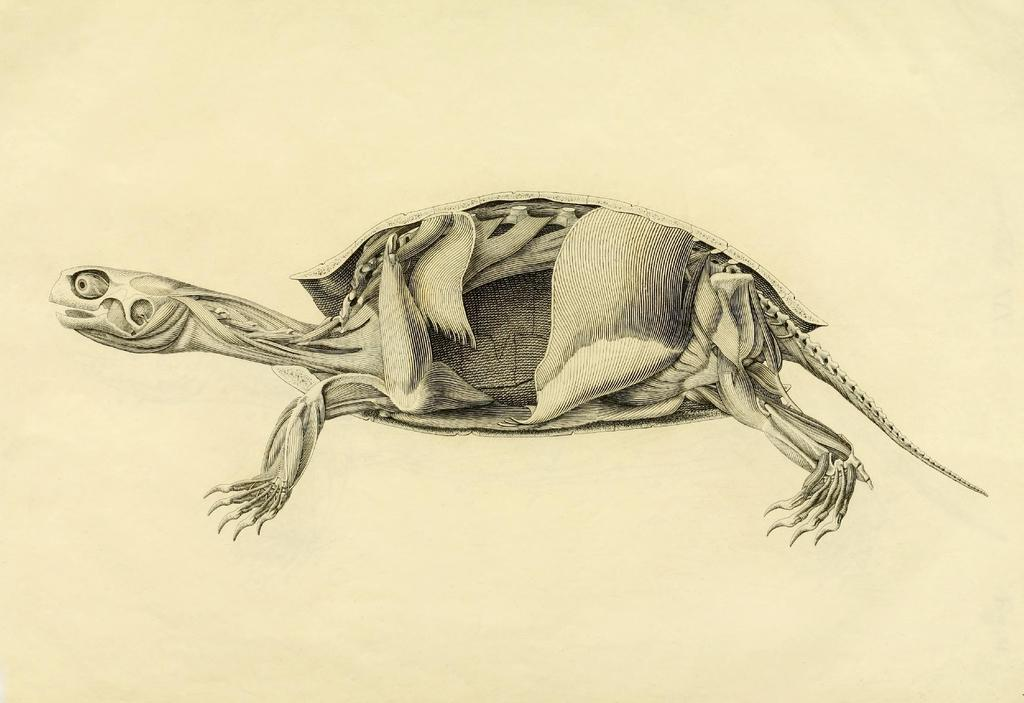What is the main subject of the image? The main subject of the image is a turtle skeleton. How is the turtle skeleton depicted in the image? The turtle skeleton appears to be drawn on paper. What is the color of the background in the image? The background color of the image is cream. What type of book can be seen in the image? There is no book present in the image; it features a turtle skeleton drawn on paper. How does the turtle skeleton interact with friction in the image? The turtle skeleton is a drawing on paper and does not interact with friction in the image. 